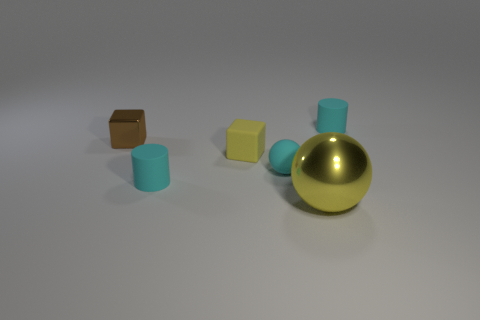Add 4 metal objects. How many objects exist? 10 Subtract all cubes. How many objects are left? 4 Subtract 0 gray blocks. How many objects are left? 6 Subtract all tiny metallic objects. Subtract all tiny cyan rubber objects. How many objects are left? 2 Add 1 cyan rubber objects. How many cyan rubber objects are left? 4 Add 6 yellow shiny balls. How many yellow shiny balls exist? 7 